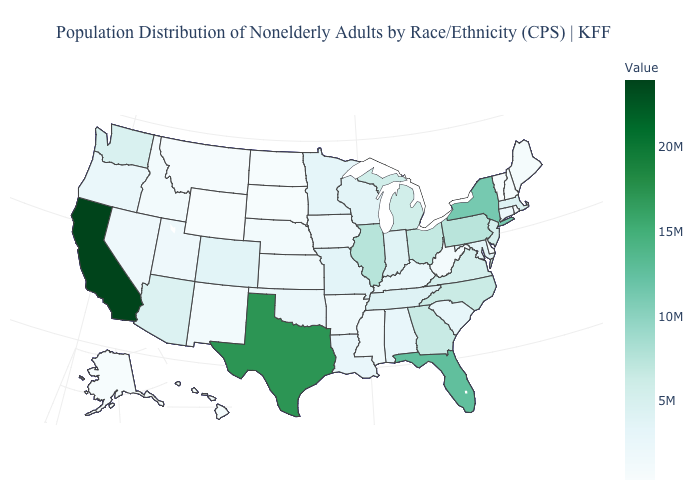Is the legend a continuous bar?
Short answer required. Yes. Which states have the lowest value in the USA?
Concise answer only. Wyoming. Among the states that border Illinois , which have the lowest value?
Short answer required. Iowa. Is the legend a continuous bar?
Concise answer only. Yes. Among the states that border West Virginia , which have the highest value?
Be succinct. Pennsylvania. Is the legend a continuous bar?
Quick response, please. Yes. Which states hav the highest value in the MidWest?
Quick response, please. Illinois. 